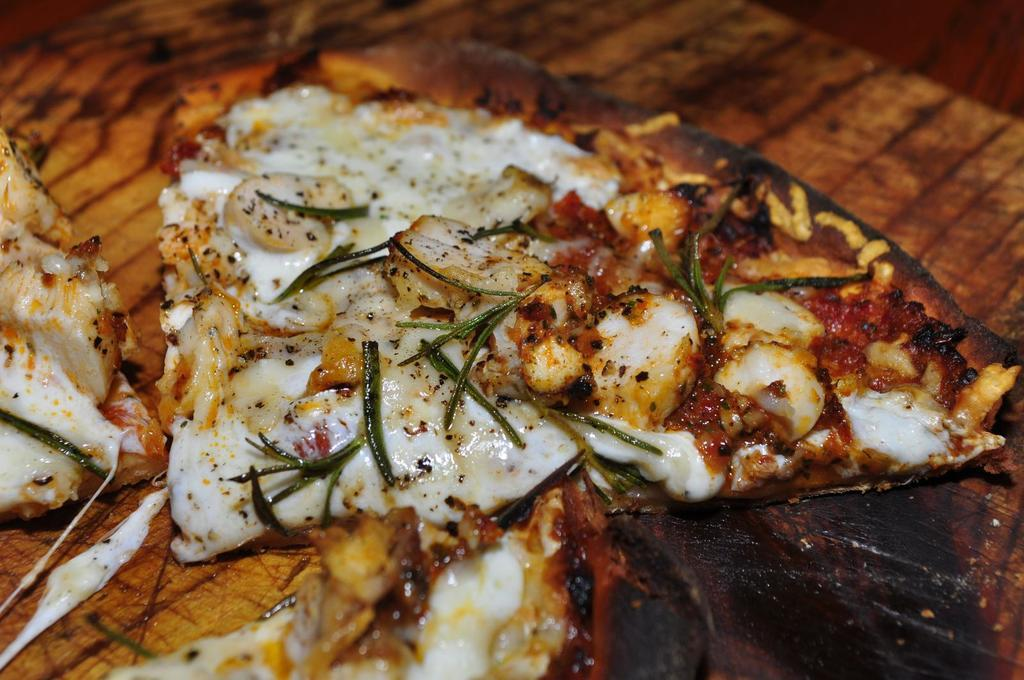What type of food is depicted in the image? There are pizza slices in the image. What type of crown is placed on top of the pizza slices in the image? There is no crown present on top of the pizza slices in the image. What is the name of the person who made the pizza slices in the image? The provided facts do not mention the name of the person who made the pizza slices, nor is there any indication of a person in the image. 